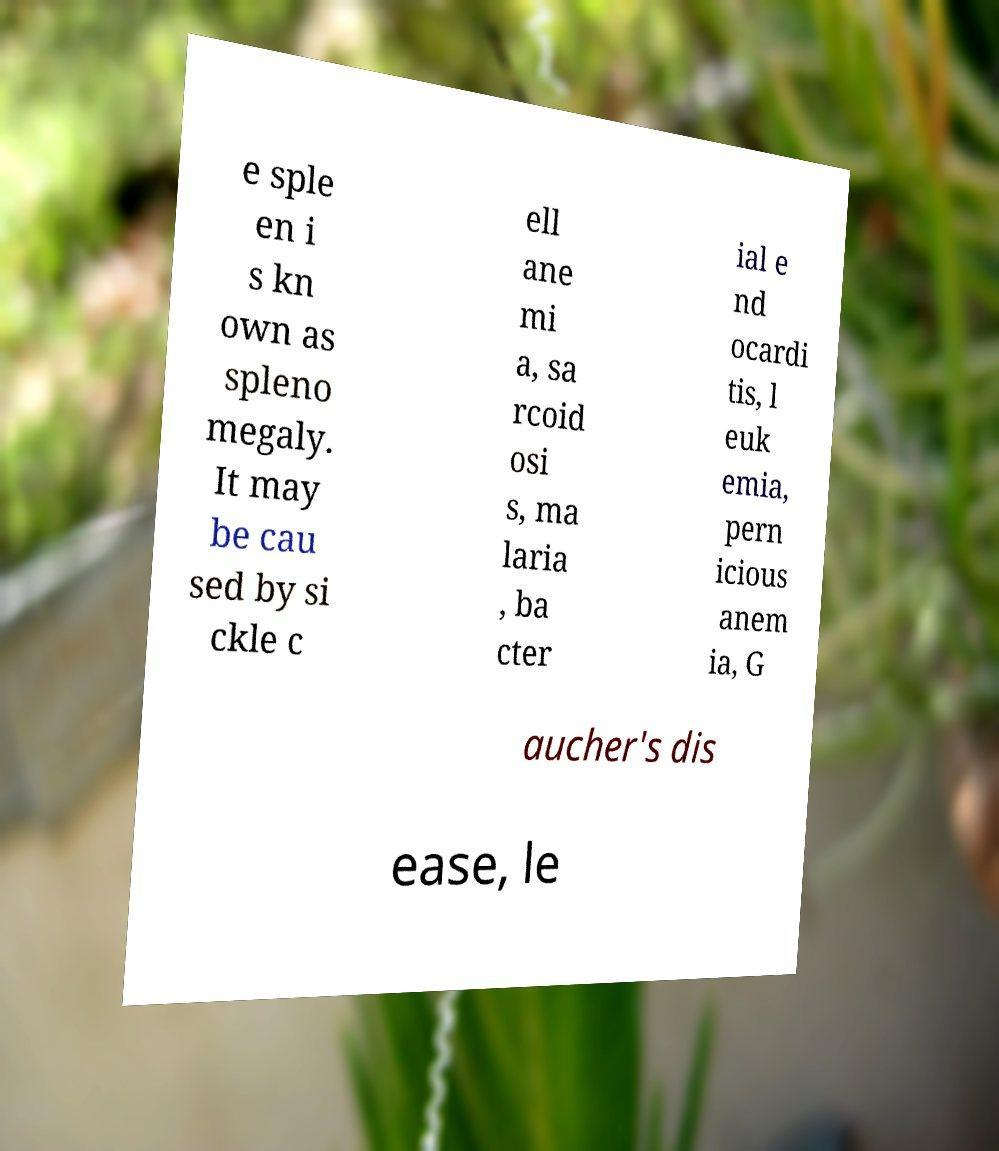For documentation purposes, I need the text within this image transcribed. Could you provide that? e sple en i s kn own as spleno megaly. It may be cau sed by si ckle c ell ane mi a, sa rcoid osi s, ma laria , ba cter ial e nd ocardi tis, l euk emia, pern icious anem ia, G aucher's dis ease, le 